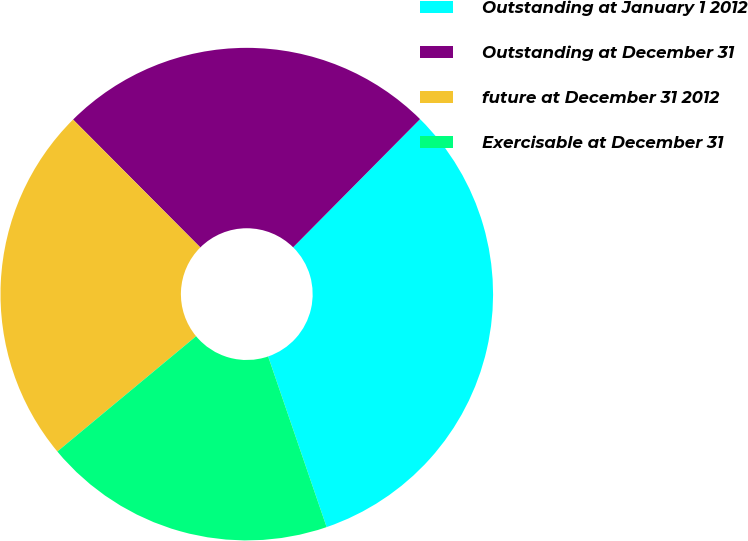Convert chart to OTSL. <chart><loc_0><loc_0><loc_500><loc_500><pie_chart><fcel>Outstanding at January 1 2012<fcel>Outstanding at December 31<fcel>future at December 31 2012<fcel>Exercisable at December 31<nl><fcel>32.32%<fcel>24.88%<fcel>23.57%<fcel>19.22%<nl></chart> 